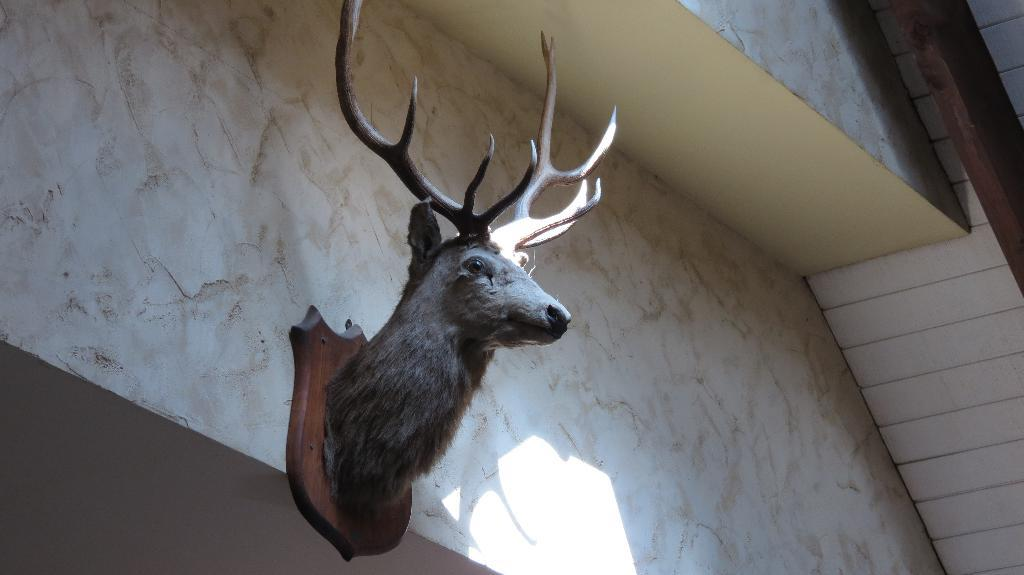What is present on the wall in the image? There is a deer mount on the wall. Can you describe the wall in the image? The wall is a flat surface with a deer mount attached to it. What type of fish can be seen swimming in the unit in the image? There is no unit or fish present in the image; it only features a wall with a deer mount. 